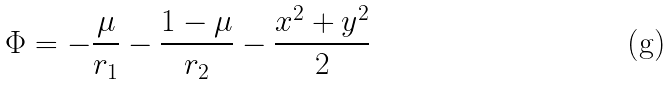<formula> <loc_0><loc_0><loc_500><loc_500>\Phi = - \frac { \mu } { r _ { 1 } } - \frac { 1 - \mu } { r _ { 2 } } - \frac { x ^ { 2 } + y ^ { 2 } } { 2 }</formula> 